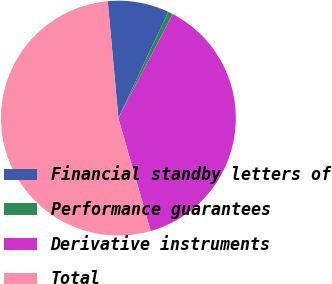Convert chart to OTSL. <chart><loc_0><loc_0><loc_500><loc_500><pie_chart><fcel>Financial standby letters of<fcel>Performance guarantees<fcel>Derivative instruments<fcel>Total<nl><fcel>8.42%<fcel>0.69%<fcel>37.9%<fcel>52.99%<nl></chart> 